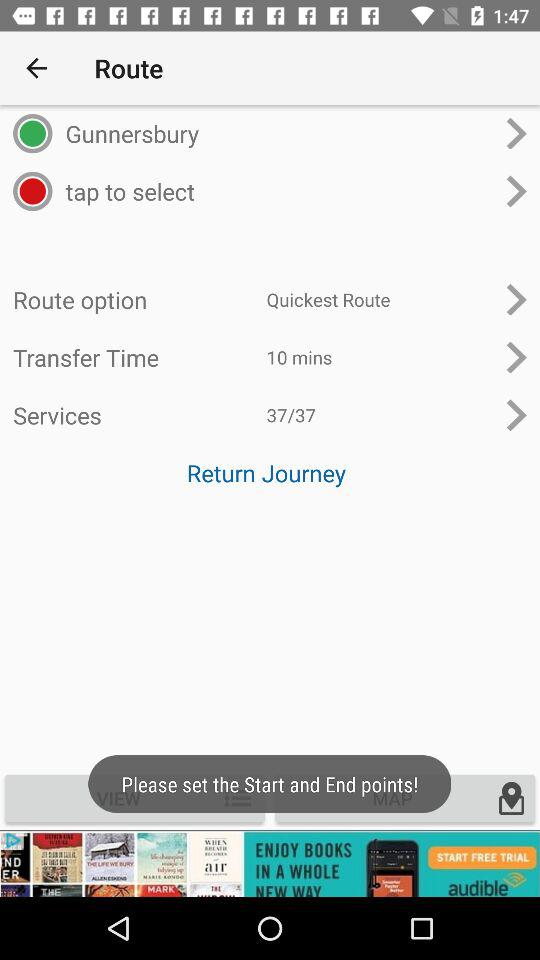What points can we set? You can set start and end points. 